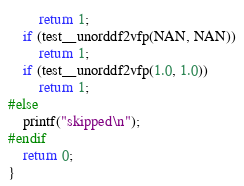Convert code to text. <code><loc_0><loc_0><loc_500><loc_500><_C_>        return 1;
    if (test__unorddf2vfp(NAN, NAN))
        return 1;
    if (test__unorddf2vfp(1.0, 1.0))
        return 1;
#else
    printf("skipped\n");
#endif
    return 0;
}
</code> 